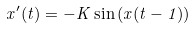Convert formula to latex. <formula><loc_0><loc_0><loc_500><loc_500>x ^ { \prime } ( t ) = - K \sin \left ( x ( t - 1 ) \right )</formula> 